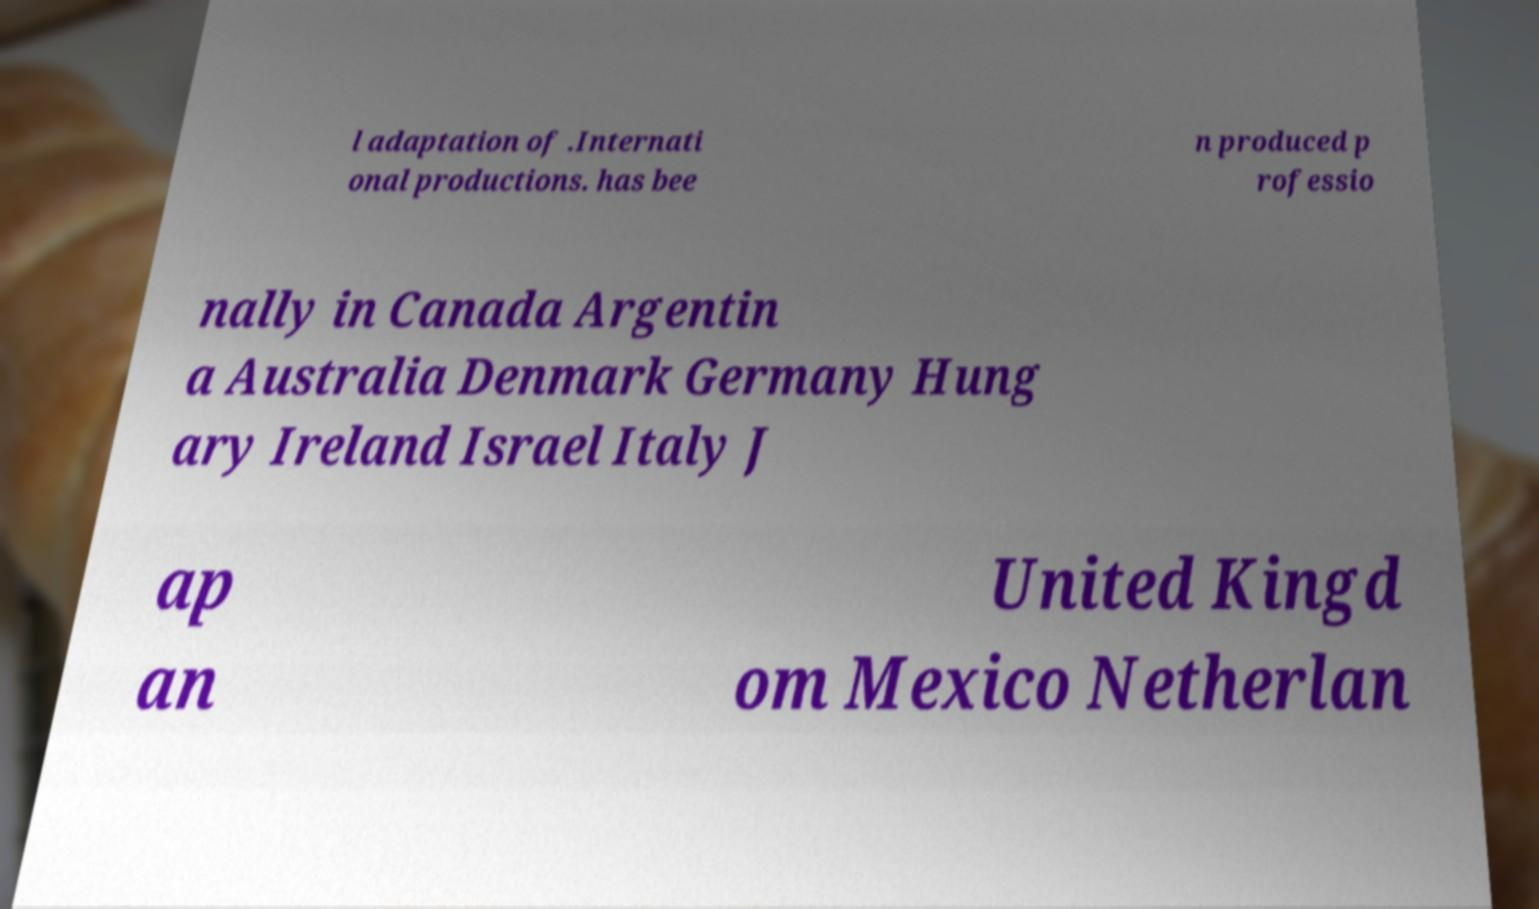Please identify and transcribe the text found in this image. l adaptation of .Internati onal productions. has bee n produced p rofessio nally in Canada Argentin a Australia Denmark Germany Hung ary Ireland Israel Italy J ap an United Kingd om Mexico Netherlan 